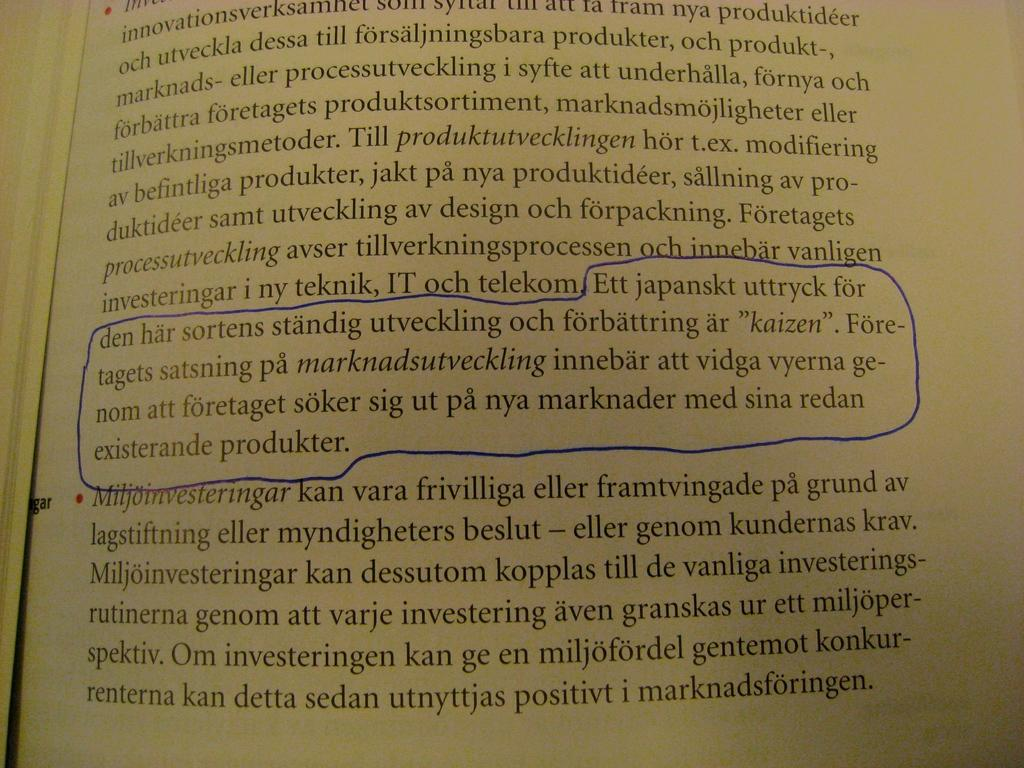<image>
Write a terse but informative summary of the picture. A book in a foreign language has a paragraph outlined in blue about a produkter 